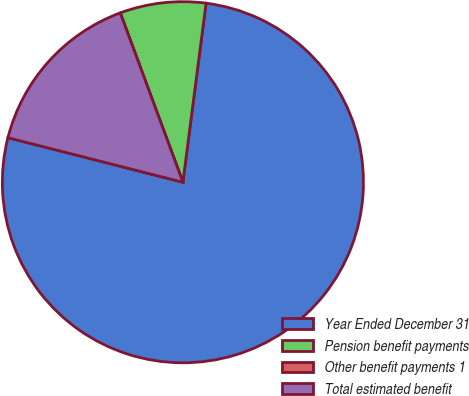<chart> <loc_0><loc_0><loc_500><loc_500><pie_chart><fcel>Year Ended December 31<fcel>Pension benefit payments<fcel>Other benefit payments 1<fcel>Total estimated benefit<nl><fcel>76.92%<fcel>7.69%<fcel>0.0%<fcel>15.39%<nl></chart> 